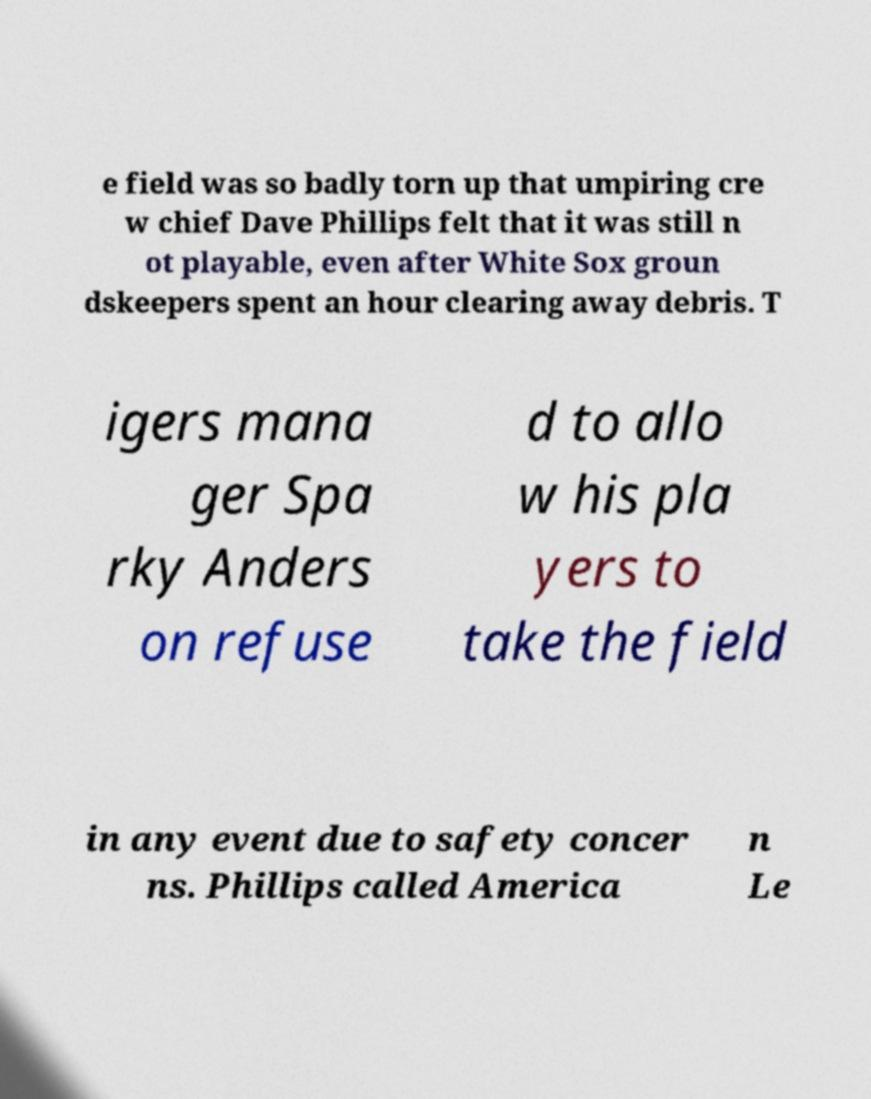Can you read and provide the text displayed in the image?This photo seems to have some interesting text. Can you extract and type it out for me? e field was so badly torn up that umpiring cre w chief Dave Phillips felt that it was still n ot playable, even after White Sox groun dskeepers spent an hour clearing away debris. T igers mana ger Spa rky Anders on refuse d to allo w his pla yers to take the field in any event due to safety concer ns. Phillips called America n Le 